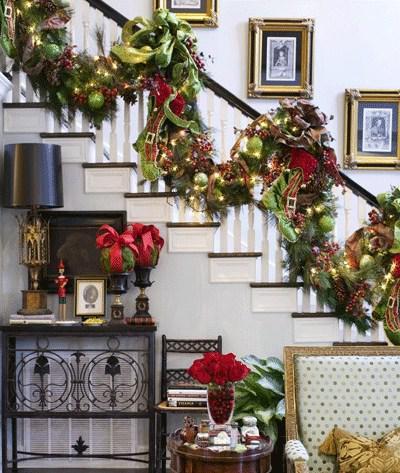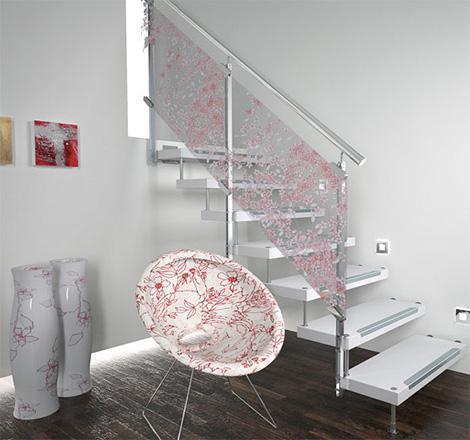The first image is the image on the left, the second image is the image on the right. For the images displayed, is the sentence "There is a railing decorated with holiday lights." factually correct? Answer yes or no. Yes. The first image is the image on the left, the second image is the image on the right. Assess this claim about the two images: "Stockings are hanging from the left staircase.". Correct or not? Answer yes or no. No. 